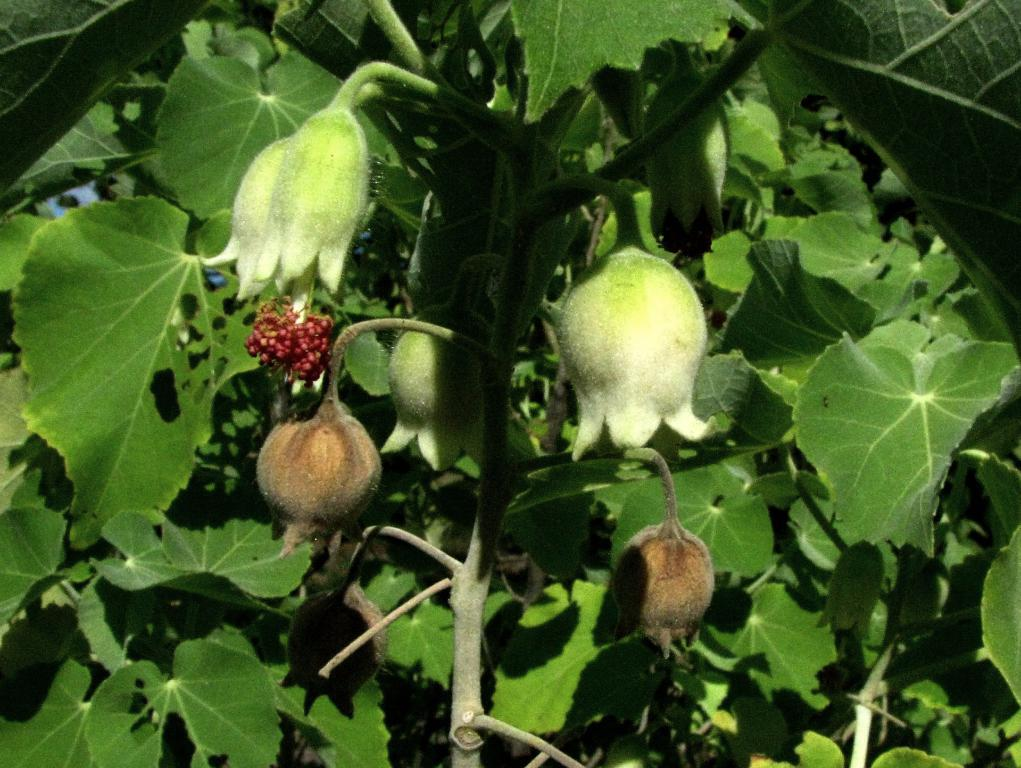What type of plants can be seen in the image? There are flowers, fruits, leaves, and stems in the image. Can you describe the different parts of the plants that are visible? Yes, there are flowers, fruits, leaves, and stems in the image. What type of bait is being used to catch fish in the image? There is no mention of fish or bait in the image; it features plants with flowers, fruits, leaves, and stems. 